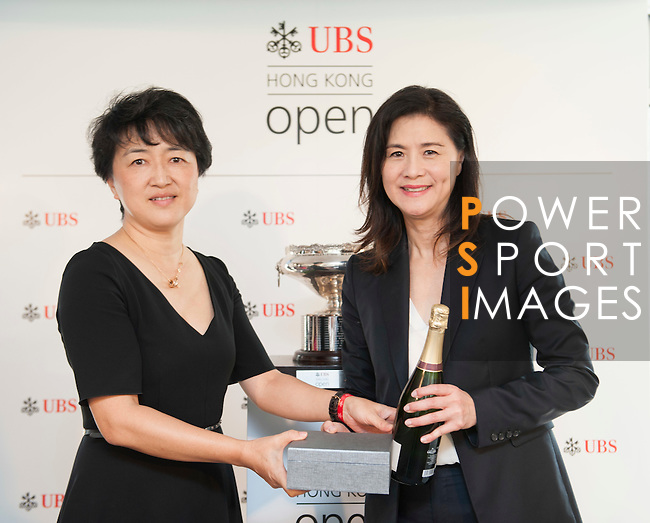Could you describe the expressions on the faces of the women in the image? Both women are smiling and appear happy and content. Their smiles seem genuine and suggest a moment of celebration or a positive experience. 